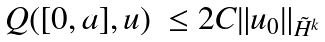Convert formula to latex. <formula><loc_0><loc_0><loc_500><loc_500>\begin{array} { l l } Q ( [ 0 , a ] , u ) & \leq 2 C \| u _ { 0 } \| _ { \tilde { H } ^ { k } } \end{array}</formula> 